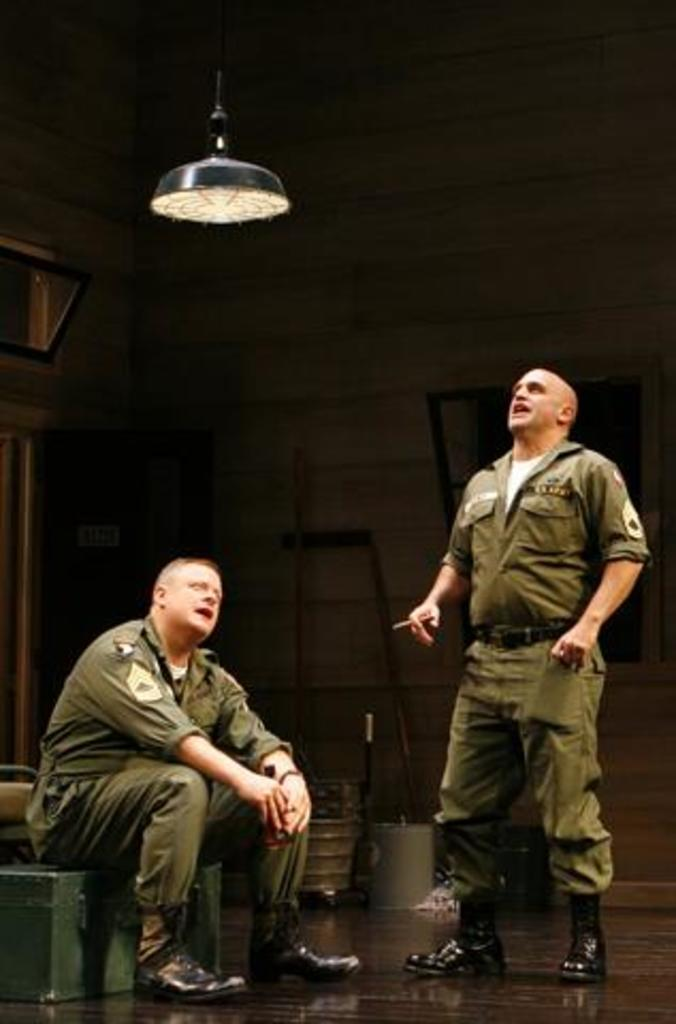What is the man sitting on in the image? The man is sitting on an iron box. What is the other man in the image doing? There is a man standing in the image. What type of lighting is present in the image? There is a lamp hanging in the image. What objects can be seen in the background of the image? In the background, there are buckets and sticks. What is the background setting of the image? There is a wall in the background. What type of rice is being cooked in the image? There is no rice present in the image. How does the zephyr affect the man standing in the image? There is no mention of a zephyr or any wind in the image, so its effect cannot be determined. 